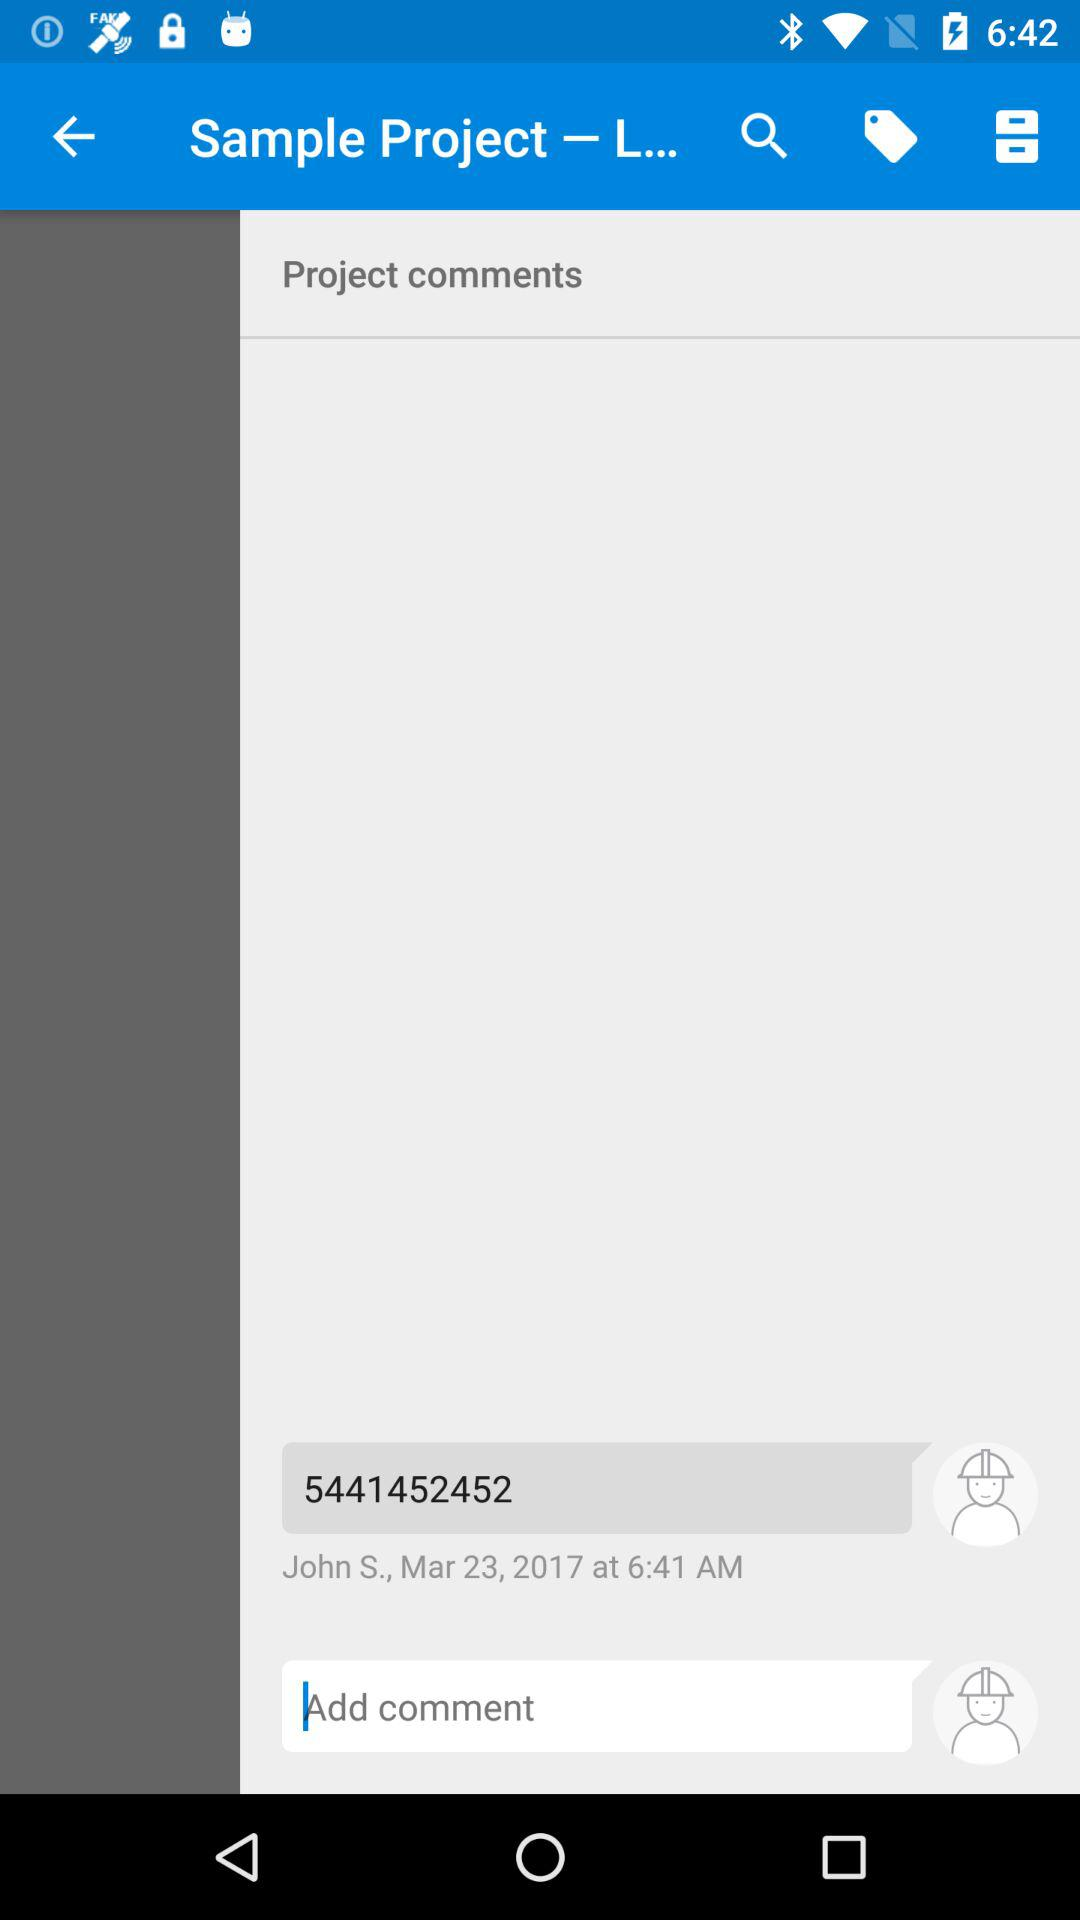How many comments are there on this project?
Answer the question using a single word or phrase. 1 